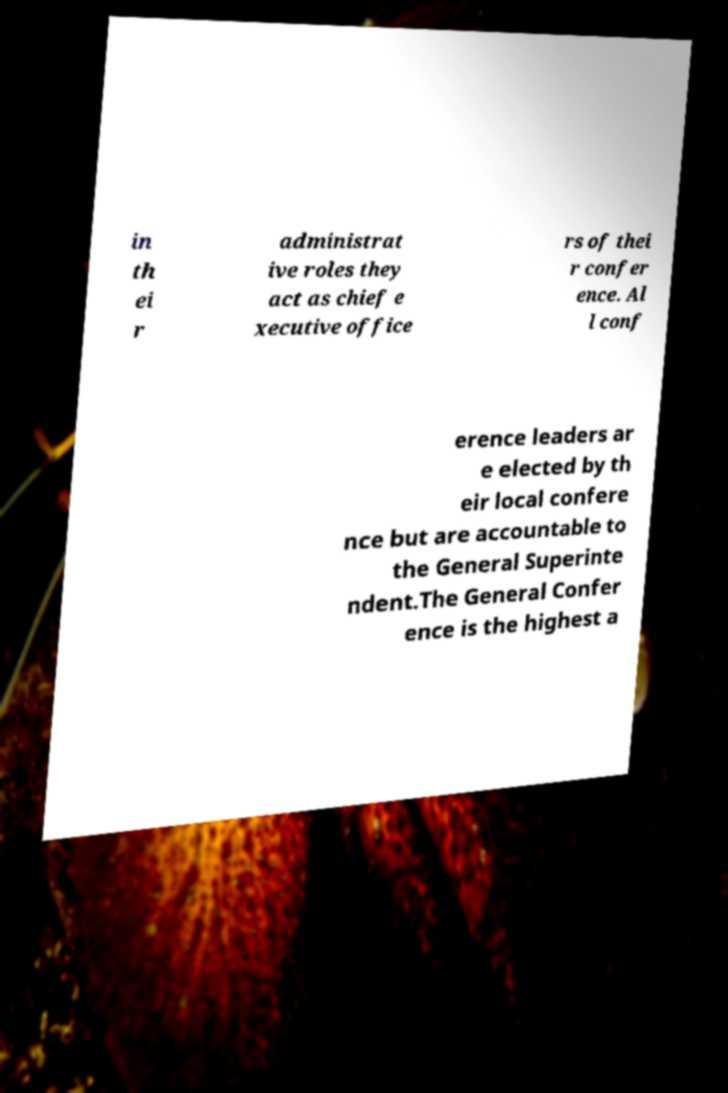Can you accurately transcribe the text from the provided image for me? in th ei r administrat ive roles they act as chief e xecutive office rs of thei r confer ence. Al l conf erence leaders ar e elected by th eir local confere nce but are accountable to the General Superinte ndent.The General Confer ence is the highest a 